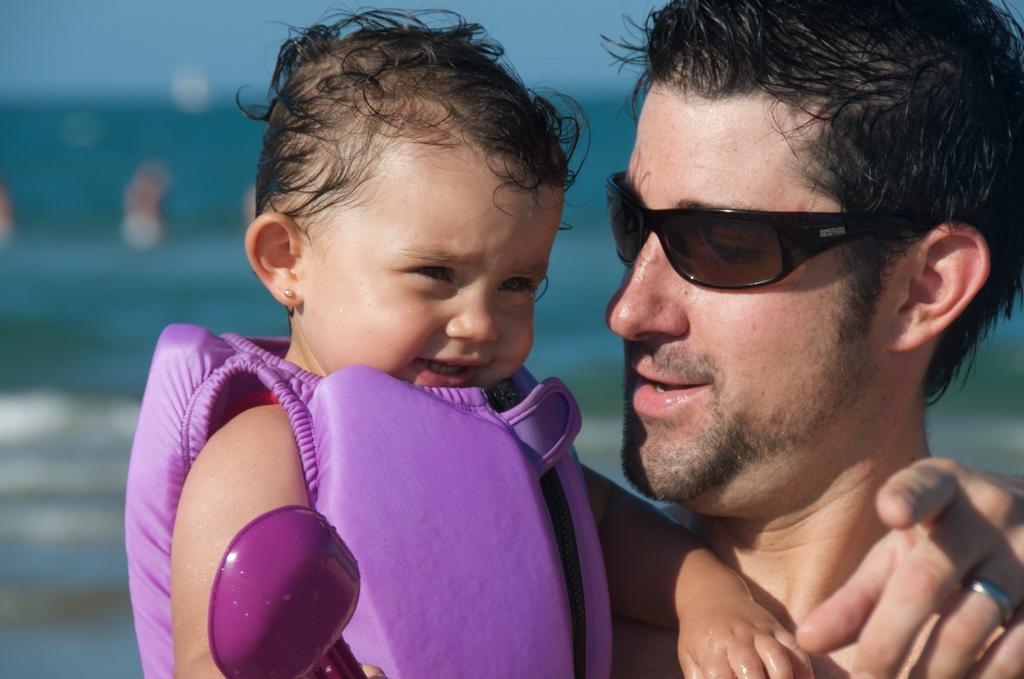Can you describe this image briefly? This picture shows a man holding a baby and he wore sunglasses on his face and the baby wore a jacket and we see few people standing on the back in the water and we see a baby holding a plastic spoon. 